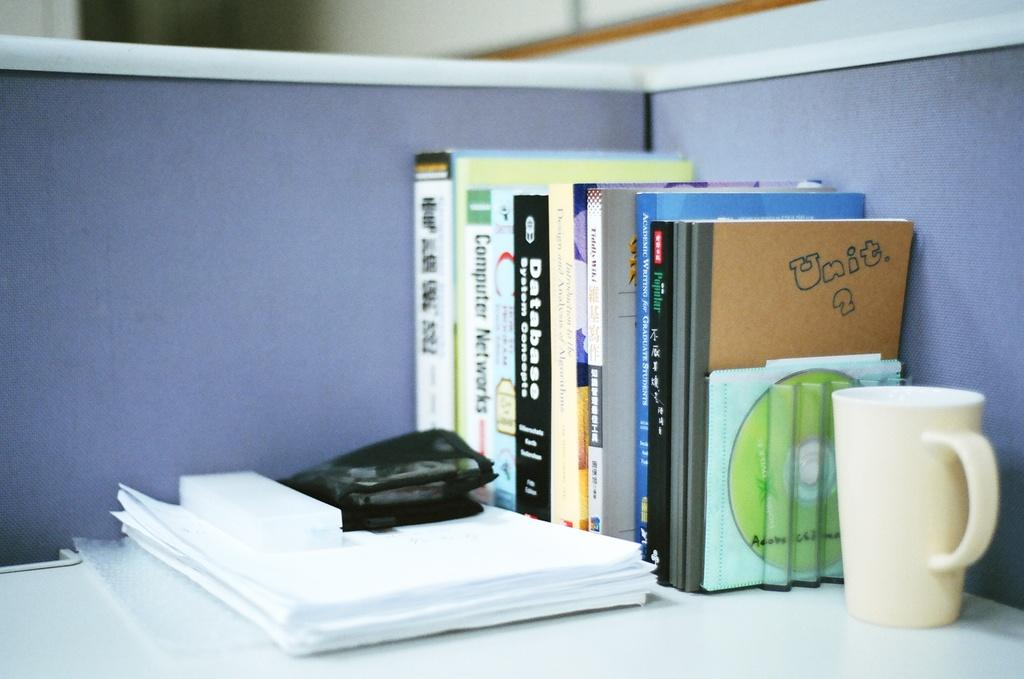What type of objects can be seen on the table in the image? There are books, a mug, and papers on the table in the image. What might be used for holding a beverage in the image? There is a mug in the image that could be used for holding a beverage. What other items are present on the table besides the mug? There are books and papers on the table in the image. What can be seen in the background of the image? There is a violet partition in the background of the image. How many times does the person in the image bite their lip? There is no person visible in the image, so it is impossible to determine how many times they might bite their lip. 